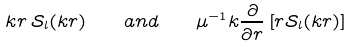Convert formula to latex. <formula><loc_0><loc_0><loc_500><loc_500>k r \, \mathcal { S } _ { l } ( k r ) \quad a n d \quad \mu ^ { - 1 } k \frac { \partial } { \partial r } \left [ r \mathcal { S } _ { l } ( k r ) \right ]</formula> 